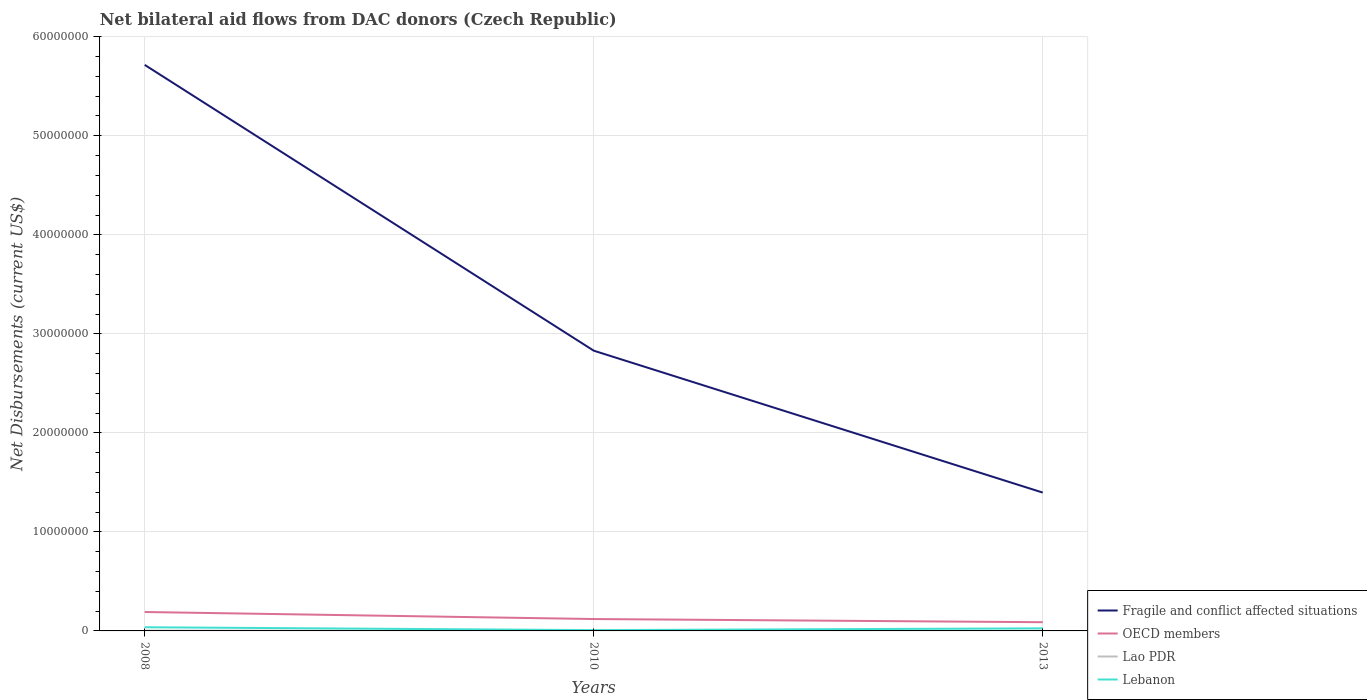How many different coloured lines are there?
Your response must be concise. 4. Does the line corresponding to Fragile and conflict affected situations intersect with the line corresponding to Lao PDR?
Your response must be concise. No. Is the number of lines equal to the number of legend labels?
Keep it short and to the point. Yes. Across all years, what is the maximum net bilateral aid flows in Lao PDR?
Offer a terse response. 10000. In which year was the net bilateral aid flows in Lao PDR maximum?
Your response must be concise. 2010. What is the total net bilateral aid flows in OECD members in the graph?
Give a very brief answer. 1.03e+06. What is the difference between the highest and the second highest net bilateral aid flows in Lao PDR?
Ensure brevity in your answer.  2.00e+04. Is the net bilateral aid flows in Lao PDR strictly greater than the net bilateral aid flows in Fragile and conflict affected situations over the years?
Your response must be concise. Yes. How many lines are there?
Your response must be concise. 4. How many years are there in the graph?
Make the answer very short. 3. What is the difference between two consecutive major ticks on the Y-axis?
Give a very brief answer. 1.00e+07. Are the values on the major ticks of Y-axis written in scientific E-notation?
Give a very brief answer. No. Does the graph contain any zero values?
Keep it short and to the point. No. Does the graph contain grids?
Your answer should be very brief. Yes. How are the legend labels stacked?
Make the answer very short. Vertical. What is the title of the graph?
Offer a terse response. Net bilateral aid flows from DAC donors (Czech Republic). Does "Sao Tome and Principe" appear as one of the legend labels in the graph?
Give a very brief answer. No. What is the label or title of the Y-axis?
Offer a very short reply. Net Disbursements (current US$). What is the Net Disbursements (current US$) of Fragile and conflict affected situations in 2008?
Your answer should be very brief. 5.72e+07. What is the Net Disbursements (current US$) of OECD members in 2008?
Ensure brevity in your answer.  1.91e+06. What is the Net Disbursements (current US$) of Lebanon in 2008?
Ensure brevity in your answer.  3.70e+05. What is the Net Disbursements (current US$) of Fragile and conflict affected situations in 2010?
Your response must be concise. 2.83e+07. What is the Net Disbursements (current US$) in OECD members in 2010?
Provide a succinct answer. 1.20e+06. What is the Net Disbursements (current US$) in Fragile and conflict affected situations in 2013?
Your answer should be compact. 1.40e+07. What is the Net Disbursements (current US$) in OECD members in 2013?
Offer a terse response. 8.80e+05. What is the Net Disbursements (current US$) of Lao PDR in 2013?
Provide a succinct answer. 10000. Across all years, what is the maximum Net Disbursements (current US$) of Fragile and conflict affected situations?
Your answer should be compact. 5.72e+07. Across all years, what is the maximum Net Disbursements (current US$) of OECD members?
Your response must be concise. 1.91e+06. Across all years, what is the maximum Net Disbursements (current US$) of Lao PDR?
Ensure brevity in your answer.  3.00e+04. Across all years, what is the maximum Net Disbursements (current US$) of Lebanon?
Provide a short and direct response. 3.70e+05. Across all years, what is the minimum Net Disbursements (current US$) of Fragile and conflict affected situations?
Offer a very short reply. 1.40e+07. Across all years, what is the minimum Net Disbursements (current US$) of OECD members?
Offer a very short reply. 8.80e+05. Across all years, what is the minimum Net Disbursements (current US$) in Lao PDR?
Provide a short and direct response. 10000. What is the total Net Disbursements (current US$) in Fragile and conflict affected situations in the graph?
Offer a very short reply. 9.94e+07. What is the total Net Disbursements (current US$) in OECD members in the graph?
Provide a succinct answer. 3.99e+06. What is the total Net Disbursements (current US$) of Lebanon in the graph?
Your response must be concise. 7.10e+05. What is the difference between the Net Disbursements (current US$) of Fragile and conflict affected situations in 2008 and that in 2010?
Ensure brevity in your answer.  2.89e+07. What is the difference between the Net Disbursements (current US$) in OECD members in 2008 and that in 2010?
Offer a very short reply. 7.10e+05. What is the difference between the Net Disbursements (current US$) of Lao PDR in 2008 and that in 2010?
Offer a terse response. 2.00e+04. What is the difference between the Net Disbursements (current US$) of Lebanon in 2008 and that in 2010?
Give a very brief answer. 2.90e+05. What is the difference between the Net Disbursements (current US$) of Fragile and conflict affected situations in 2008 and that in 2013?
Offer a terse response. 4.32e+07. What is the difference between the Net Disbursements (current US$) in OECD members in 2008 and that in 2013?
Offer a terse response. 1.03e+06. What is the difference between the Net Disbursements (current US$) in Lao PDR in 2008 and that in 2013?
Offer a terse response. 2.00e+04. What is the difference between the Net Disbursements (current US$) of Lebanon in 2008 and that in 2013?
Your response must be concise. 1.10e+05. What is the difference between the Net Disbursements (current US$) in Fragile and conflict affected situations in 2010 and that in 2013?
Offer a terse response. 1.43e+07. What is the difference between the Net Disbursements (current US$) of OECD members in 2010 and that in 2013?
Offer a very short reply. 3.20e+05. What is the difference between the Net Disbursements (current US$) in Lao PDR in 2010 and that in 2013?
Ensure brevity in your answer.  0. What is the difference between the Net Disbursements (current US$) of Lebanon in 2010 and that in 2013?
Provide a succinct answer. -1.80e+05. What is the difference between the Net Disbursements (current US$) of Fragile and conflict affected situations in 2008 and the Net Disbursements (current US$) of OECD members in 2010?
Offer a terse response. 5.60e+07. What is the difference between the Net Disbursements (current US$) of Fragile and conflict affected situations in 2008 and the Net Disbursements (current US$) of Lao PDR in 2010?
Provide a succinct answer. 5.72e+07. What is the difference between the Net Disbursements (current US$) in Fragile and conflict affected situations in 2008 and the Net Disbursements (current US$) in Lebanon in 2010?
Provide a short and direct response. 5.71e+07. What is the difference between the Net Disbursements (current US$) in OECD members in 2008 and the Net Disbursements (current US$) in Lao PDR in 2010?
Your answer should be compact. 1.90e+06. What is the difference between the Net Disbursements (current US$) of OECD members in 2008 and the Net Disbursements (current US$) of Lebanon in 2010?
Keep it short and to the point. 1.83e+06. What is the difference between the Net Disbursements (current US$) of Fragile and conflict affected situations in 2008 and the Net Disbursements (current US$) of OECD members in 2013?
Keep it short and to the point. 5.63e+07. What is the difference between the Net Disbursements (current US$) in Fragile and conflict affected situations in 2008 and the Net Disbursements (current US$) in Lao PDR in 2013?
Your response must be concise. 5.72e+07. What is the difference between the Net Disbursements (current US$) of Fragile and conflict affected situations in 2008 and the Net Disbursements (current US$) of Lebanon in 2013?
Give a very brief answer. 5.69e+07. What is the difference between the Net Disbursements (current US$) in OECD members in 2008 and the Net Disbursements (current US$) in Lao PDR in 2013?
Give a very brief answer. 1.90e+06. What is the difference between the Net Disbursements (current US$) of OECD members in 2008 and the Net Disbursements (current US$) of Lebanon in 2013?
Your answer should be compact. 1.65e+06. What is the difference between the Net Disbursements (current US$) of Lao PDR in 2008 and the Net Disbursements (current US$) of Lebanon in 2013?
Your answer should be compact. -2.30e+05. What is the difference between the Net Disbursements (current US$) in Fragile and conflict affected situations in 2010 and the Net Disbursements (current US$) in OECD members in 2013?
Offer a terse response. 2.74e+07. What is the difference between the Net Disbursements (current US$) in Fragile and conflict affected situations in 2010 and the Net Disbursements (current US$) in Lao PDR in 2013?
Your answer should be compact. 2.83e+07. What is the difference between the Net Disbursements (current US$) in Fragile and conflict affected situations in 2010 and the Net Disbursements (current US$) in Lebanon in 2013?
Your answer should be very brief. 2.80e+07. What is the difference between the Net Disbursements (current US$) of OECD members in 2010 and the Net Disbursements (current US$) of Lao PDR in 2013?
Make the answer very short. 1.19e+06. What is the difference between the Net Disbursements (current US$) in OECD members in 2010 and the Net Disbursements (current US$) in Lebanon in 2013?
Offer a very short reply. 9.40e+05. What is the average Net Disbursements (current US$) of Fragile and conflict affected situations per year?
Ensure brevity in your answer.  3.31e+07. What is the average Net Disbursements (current US$) in OECD members per year?
Ensure brevity in your answer.  1.33e+06. What is the average Net Disbursements (current US$) of Lao PDR per year?
Keep it short and to the point. 1.67e+04. What is the average Net Disbursements (current US$) of Lebanon per year?
Your response must be concise. 2.37e+05. In the year 2008, what is the difference between the Net Disbursements (current US$) of Fragile and conflict affected situations and Net Disbursements (current US$) of OECD members?
Provide a short and direct response. 5.52e+07. In the year 2008, what is the difference between the Net Disbursements (current US$) in Fragile and conflict affected situations and Net Disbursements (current US$) in Lao PDR?
Offer a terse response. 5.71e+07. In the year 2008, what is the difference between the Net Disbursements (current US$) of Fragile and conflict affected situations and Net Disbursements (current US$) of Lebanon?
Provide a short and direct response. 5.68e+07. In the year 2008, what is the difference between the Net Disbursements (current US$) of OECD members and Net Disbursements (current US$) of Lao PDR?
Keep it short and to the point. 1.88e+06. In the year 2008, what is the difference between the Net Disbursements (current US$) in OECD members and Net Disbursements (current US$) in Lebanon?
Your response must be concise. 1.54e+06. In the year 2008, what is the difference between the Net Disbursements (current US$) in Lao PDR and Net Disbursements (current US$) in Lebanon?
Make the answer very short. -3.40e+05. In the year 2010, what is the difference between the Net Disbursements (current US$) of Fragile and conflict affected situations and Net Disbursements (current US$) of OECD members?
Your answer should be very brief. 2.71e+07. In the year 2010, what is the difference between the Net Disbursements (current US$) in Fragile and conflict affected situations and Net Disbursements (current US$) in Lao PDR?
Offer a terse response. 2.83e+07. In the year 2010, what is the difference between the Net Disbursements (current US$) in Fragile and conflict affected situations and Net Disbursements (current US$) in Lebanon?
Keep it short and to the point. 2.82e+07. In the year 2010, what is the difference between the Net Disbursements (current US$) of OECD members and Net Disbursements (current US$) of Lao PDR?
Your response must be concise. 1.19e+06. In the year 2010, what is the difference between the Net Disbursements (current US$) of OECD members and Net Disbursements (current US$) of Lebanon?
Your response must be concise. 1.12e+06. In the year 2013, what is the difference between the Net Disbursements (current US$) in Fragile and conflict affected situations and Net Disbursements (current US$) in OECD members?
Your response must be concise. 1.31e+07. In the year 2013, what is the difference between the Net Disbursements (current US$) of Fragile and conflict affected situations and Net Disbursements (current US$) of Lao PDR?
Your response must be concise. 1.40e+07. In the year 2013, what is the difference between the Net Disbursements (current US$) of Fragile and conflict affected situations and Net Disbursements (current US$) of Lebanon?
Provide a succinct answer. 1.37e+07. In the year 2013, what is the difference between the Net Disbursements (current US$) of OECD members and Net Disbursements (current US$) of Lao PDR?
Make the answer very short. 8.70e+05. In the year 2013, what is the difference between the Net Disbursements (current US$) of OECD members and Net Disbursements (current US$) of Lebanon?
Your answer should be compact. 6.20e+05. In the year 2013, what is the difference between the Net Disbursements (current US$) of Lao PDR and Net Disbursements (current US$) of Lebanon?
Give a very brief answer. -2.50e+05. What is the ratio of the Net Disbursements (current US$) of Fragile and conflict affected situations in 2008 to that in 2010?
Make the answer very short. 2.02. What is the ratio of the Net Disbursements (current US$) in OECD members in 2008 to that in 2010?
Your answer should be very brief. 1.59. What is the ratio of the Net Disbursements (current US$) of Lebanon in 2008 to that in 2010?
Your answer should be very brief. 4.62. What is the ratio of the Net Disbursements (current US$) of Fragile and conflict affected situations in 2008 to that in 2013?
Offer a terse response. 4.09. What is the ratio of the Net Disbursements (current US$) in OECD members in 2008 to that in 2013?
Make the answer very short. 2.17. What is the ratio of the Net Disbursements (current US$) of Lebanon in 2008 to that in 2013?
Your answer should be very brief. 1.42. What is the ratio of the Net Disbursements (current US$) in Fragile and conflict affected situations in 2010 to that in 2013?
Your answer should be compact. 2.03. What is the ratio of the Net Disbursements (current US$) of OECD members in 2010 to that in 2013?
Make the answer very short. 1.36. What is the ratio of the Net Disbursements (current US$) in Lao PDR in 2010 to that in 2013?
Ensure brevity in your answer.  1. What is the ratio of the Net Disbursements (current US$) in Lebanon in 2010 to that in 2013?
Ensure brevity in your answer.  0.31. What is the difference between the highest and the second highest Net Disbursements (current US$) in Fragile and conflict affected situations?
Offer a terse response. 2.89e+07. What is the difference between the highest and the second highest Net Disbursements (current US$) of OECD members?
Your response must be concise. 7.10e+05. What is the difference between the highest and the second highest Net Disbursements (current US$) of Lao PDR?
Make the answer very short. 2.00e+04. What is the difference between the highest and the lowest Net Disbursements (current US$) in Fragile and conflict affected situations?
Provide a succinct answer. 4.32e+07. What is the difference between the highest and the lowest Net Disbursements (current US$) of OECD members?
Provide a short and direct response. 1.03e+06. What is the difference between the highest and the lowest Net Disbursements (current US$) of Lao PDR?
Provide a short and direct response. 2.00e+04. What is the difference between the highest and the lowest Net Disbursements (current US$) in Lebanon?
Ensure brevity in your answer.  2.90e+05. 